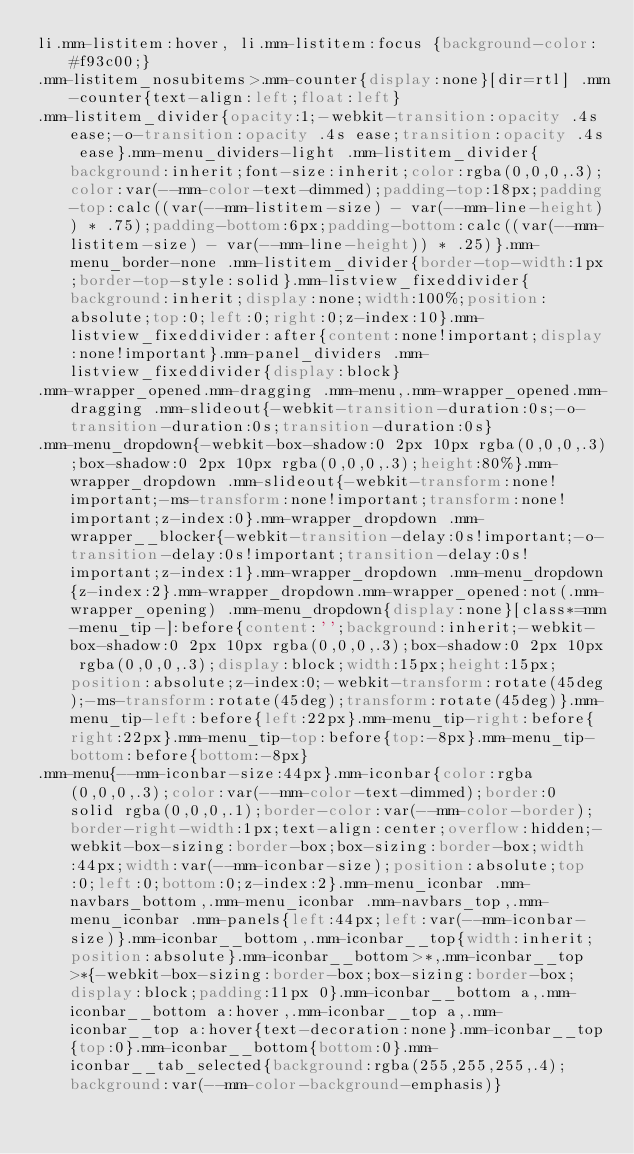<code> <loc_0><loc_0><loc_500><loc_500><_CSS_>li.mm-listitem:hover, li.mm-listitem:focus {background-color: #f93c00;}
.mm-listitem_nosubitems>.mm-counter{display:none}[dir=rtl] .mm-counter{text-align:left;float:left}
.mm-listitem_divider{opacity:1;-webkit-transition:opacity .4s ease;-o-transition:opacity .4s ease;transition:opacity .4s ease}.mm-menu_dividers-light .mm-listitem_divider{background:inherit;font-size:inherit;color:rgba(0,0,0,.3);color:var(--mm-color-text-dimmed);padding-top:18px;padding-top:calc((var(--mm-listitem-size) - var(--mm-line-height)) * .75);padding-bottom:6px;padding-bottom:calc((var(--mm-listitem-size) - var(--mm-line-height)) * .25)}.mm-menu_border-none .mm-listitem_divider{border-top-width:1px;border-top-style:solid}.mm-listview_fixeddivider{background:inherit;display:none;width:100%;position:absolute;top:0;left:0;right:0;z-index:10}.mm-listview_fixeddivider:after{content:none!important;display:none!important}.mm-panel_dividers .mm-listview_fixeddivider{display:block}
.mm-wrapper_opened.mm-dragging .mm-menu,.mm-wrapper_opened.mm-dragging .mm-slideout{-webkit-transition-duration:0s;-o-transition-duration:0s;transition-duration:0s}
.mm-menu_dropdown{-webkit-box-shadow:0 2px 10px rgba(0,0,0,.3);box-shadow:0 2px 10px rgba(0,0,0,.3);height:80%}.mm-wrapper_dropdown .mm-slideout{-webkit-transform:none!important;-ms-transform:none!important;transform:none!important;z-index:0}.mm-wrapper_dropdown .mm-wrapper__blocker{-webkit-transition-delay:0s!important;-o-transition-delay:0s!important;transition-delay:0s!important;z-index:1}.mm-wrapper_dropdown .mm-menu_dropdown{z-index:2}.mm-wrapper_dropdown.mm-wrapper_opened:not(.mm-wrapper_opening) .mm-menu_dropdown{display:none}[class*=mm-menu_tip-]:before{content:'';background:inherit;-webkit-box-shadow:0 2px 10px rgba(0,0,0,.3);box-shadow:0 2px 10px rgba(0,0,0,.3);display:block;width:15px;height:15px;position:absolute;z-index:0;-webkit-transform:rotate(45deg);-ms-transform:rotate(45deg);transform:rotate(45deg)}.mm-menu_tip-left:before{left:22px}.mm-menu_tip-right:before{right:22px}.mm-menu_tip-top:before{top:-8px}.mm-menu_tip-bottom:before{bottom:-8px}
.mm-menu{--mm-iconbar-size:44px}.mm-iconbar{color:rgba(0,0,0,.3);color:var(--mm-color-text-dimmed);border:0 solid rgba(0,0,0,.1);border-color:var(--mm-color-border);border-right-width:1px;text-align:center;overflow:hidden;-webkit-box-sizing:border-box;box-sizing:border-box;width:44px;width:var(--mm-iconbar-size);position:absolute;top:0;left:0;bottom:0;z-index:2}.mm-menu_iconbar .mm-navbars_bottom,.mm-menu_iconbar .mm-navbars_top,.mm-menu_iconbar .mm-panels{left:44px;left:var(--mm-iconbar-size)}.mm-iconbar__bottom,.mm-iconbar__top{width:inherit;position:absolute}.mm-iconbar__bottom>*,.mm-iconbar__top>*{-webkit-box-sizing:border-box;box-sizing:border-box;display:block;padding:11px 0}.mm-iconbar__bottom a,.mm-iconbar__bottom a:hover,.mm-iconbar__top a,.mm-iconbar__top a:hover{text-decoration:none}.mm-iconbar__top{top:0}.mm-iconbar__bottom{bottom:0}.mm-iconbar__tab_selected{background:rgba(255,255,255,.4);background:var(--mm-color-background-emphasis)}</code> 